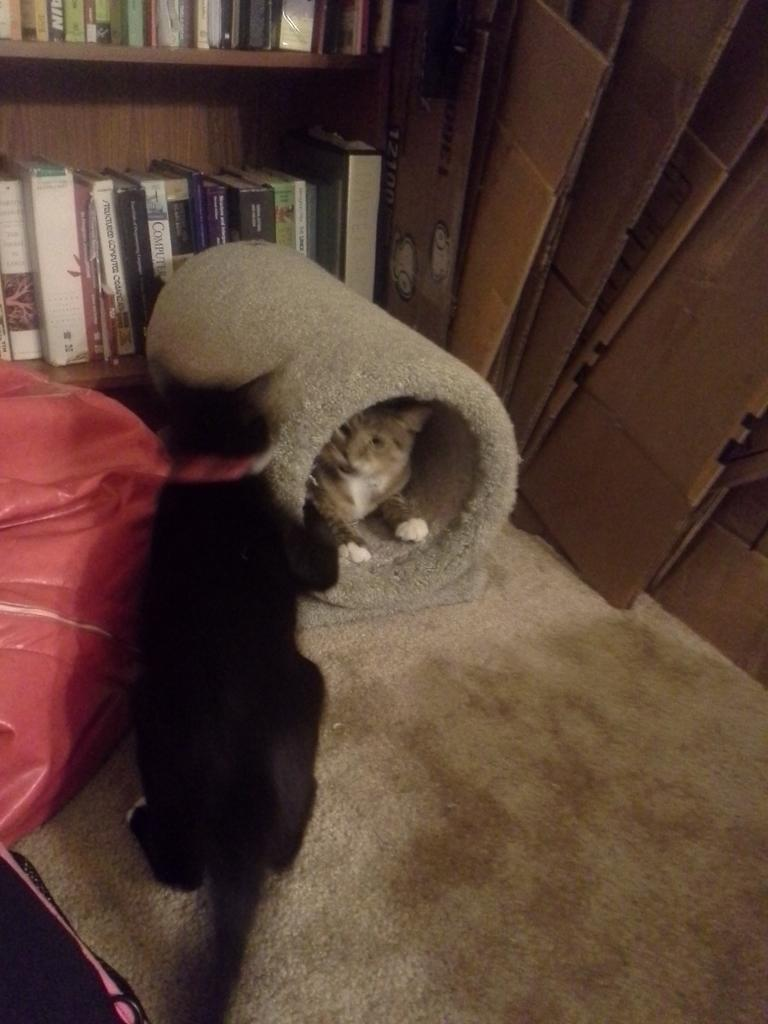What type of animal can be seen in the image? There is a cat on a carpet in the image. What other object is visible in the image? There is a bag in the image. What material is present in the image? There are boards in the image. Can you describe the cat's location in the image? There is a cat on the floor in the image. What can be found on the shelves in the image? There is a group of books on the shelves in the image. What holiday is being celebrated in the image? There is no indication of a holiday being celebrated in the image. How many cats are present in the image? There is only one cat present in the image. 